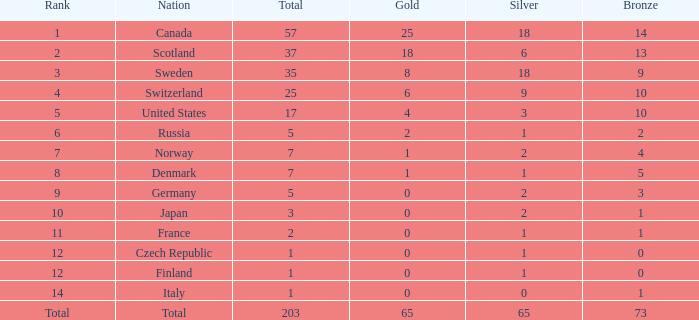What is the lowest total when the rank is 14 and the gold medals is larger than 0? None. 